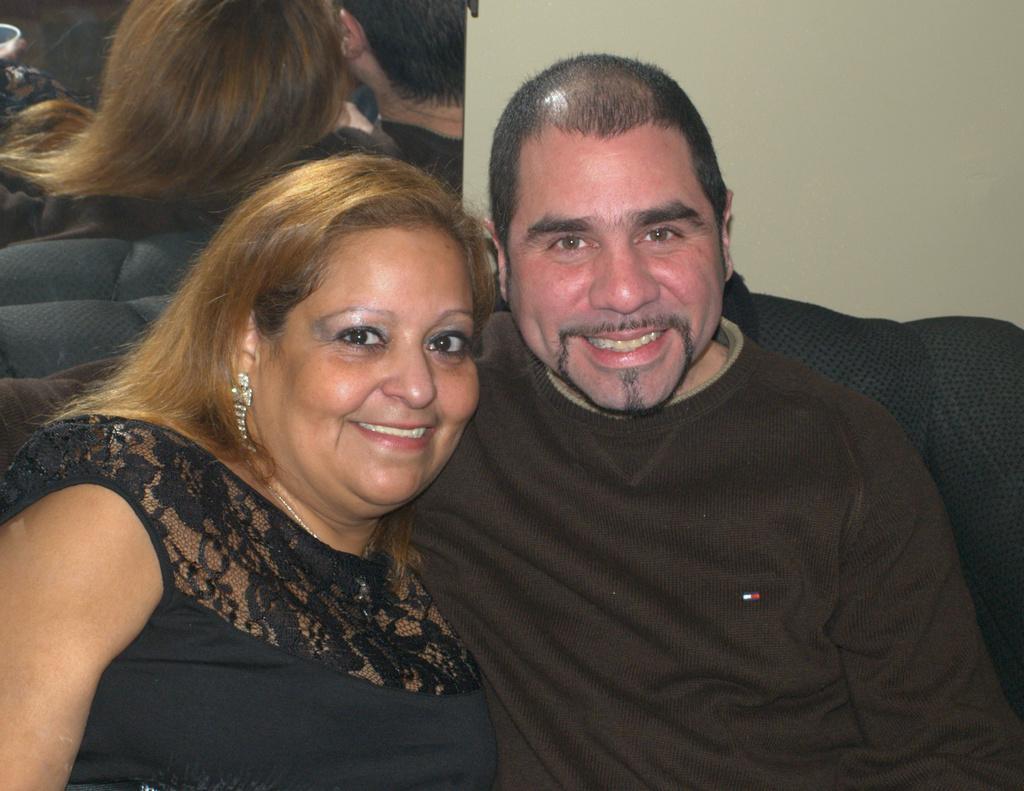In one or two sentences, can you explain what this image depicts? In the picture I can see a woman and man are wearing black color dress and smiling. In the background, we can see their reflection in the mirror which is fixed to the wall. 